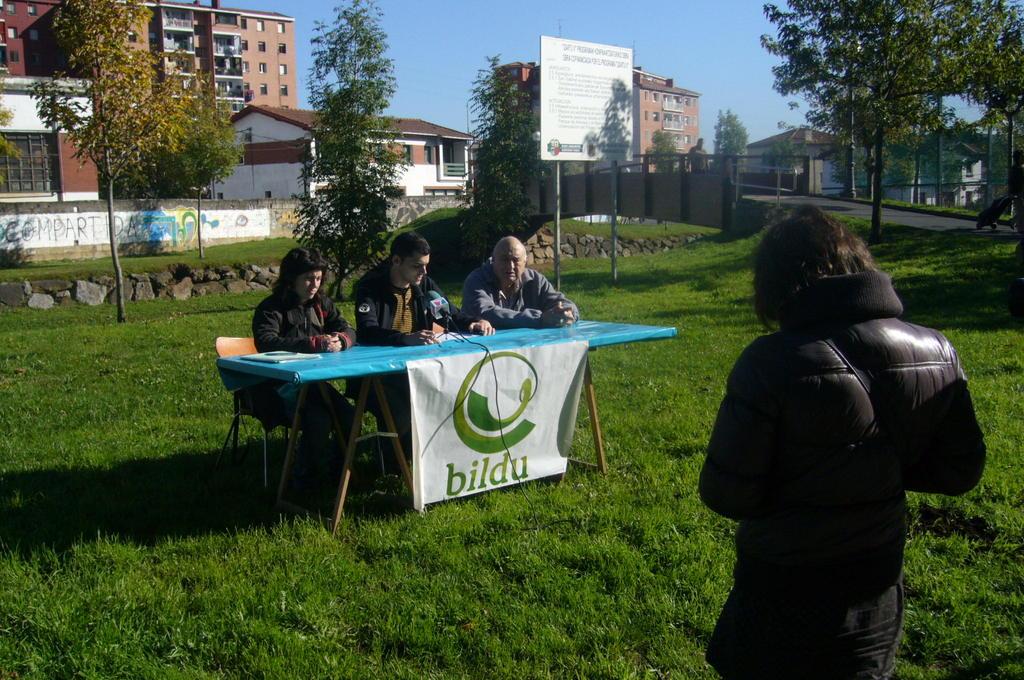What is the name on the table banner?
Provide a succinct answer. Bildu. What are they sitting are the desk for?
Make the answer very short. Bildu. 